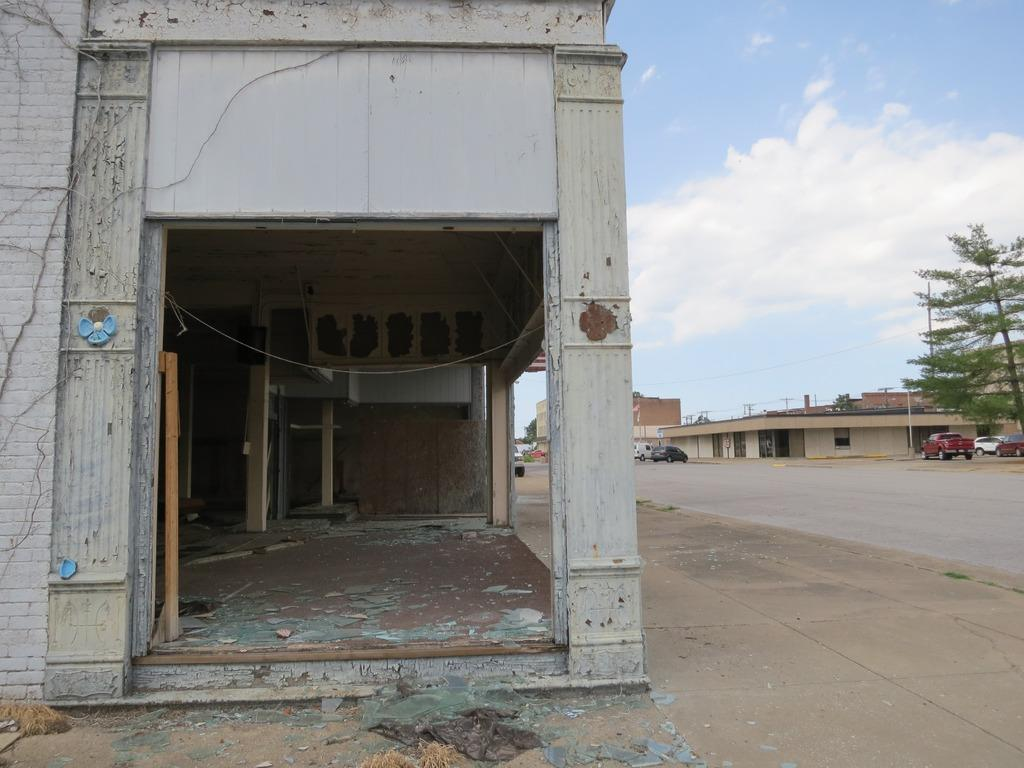What type of structure can be seen in the image? There is a wall in the image, and there are pillars, a floor, and buildings visible in the background. What is located in the background of the image? In the background of the image, there is a road, vehicles, trees, poles, buildings, and the sky. What can be seen in the sky in the image? The sky is visible in the background of the image, and there are clouds present. What type of veil is draped over the wall in the image? There is no veil present in the image; the wall is visible without any covering. Can you see a pencil being used by the fireman in the image? There is no fireman or pencil present in the image. 